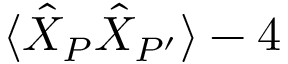Convert formula to latex. <formula><loc_0><loc_0><loc_500><loc_500>\langle \hat { X } _ { P } \hat { X } _ { P ^ { \prime } } \rangle - 4</formula> 